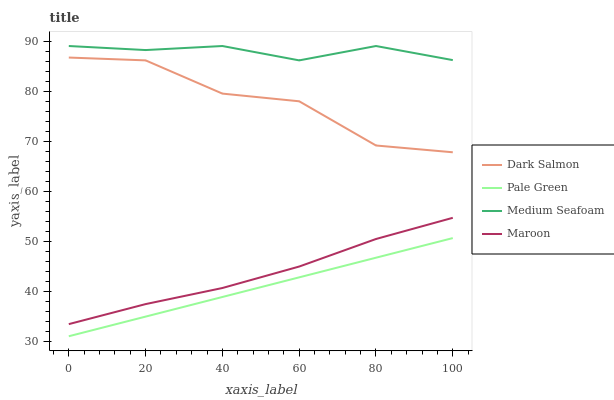Does Pale Green have the minimum area under the curve?
Answer yes or no. Yes. Does Medium Seafoam have the maximum area under the curve?
Answer yes or no. Yes. Does Dark Salmon have the minimum area under the curve?
Answer yes or no. No. Does Dark Salmon have the maximum area under the curve?
Answer yes or no. No. Is Pale Green the smoothest?
Answer yes or no. Yes. Is Dark Salmon the roughest?
Answer yes or no. Yes. Is Maroon the smoothest?
Answer yes or no. No. Is Maroon the roughest?
Answer yes or no. No. Does Pale Green have the lowest value?
Answer yes or no. Yes. Does Dark Salmon have the lowest value?
Answer yes or no. No. Does Medium Seafoam have the highest value?
Answer yes or no. Yes. Does Dark Salmon have the highest value?
Answer yes or no. No. Is Pale Green less than Dark Salmon?
Answer yes or no. Yes. Is Medium Seafoam greater than Dark Salmon?
Answer yes or no. Yes. Does Pale Green intersect Dark Salmon?
Answer yes or no. No. 